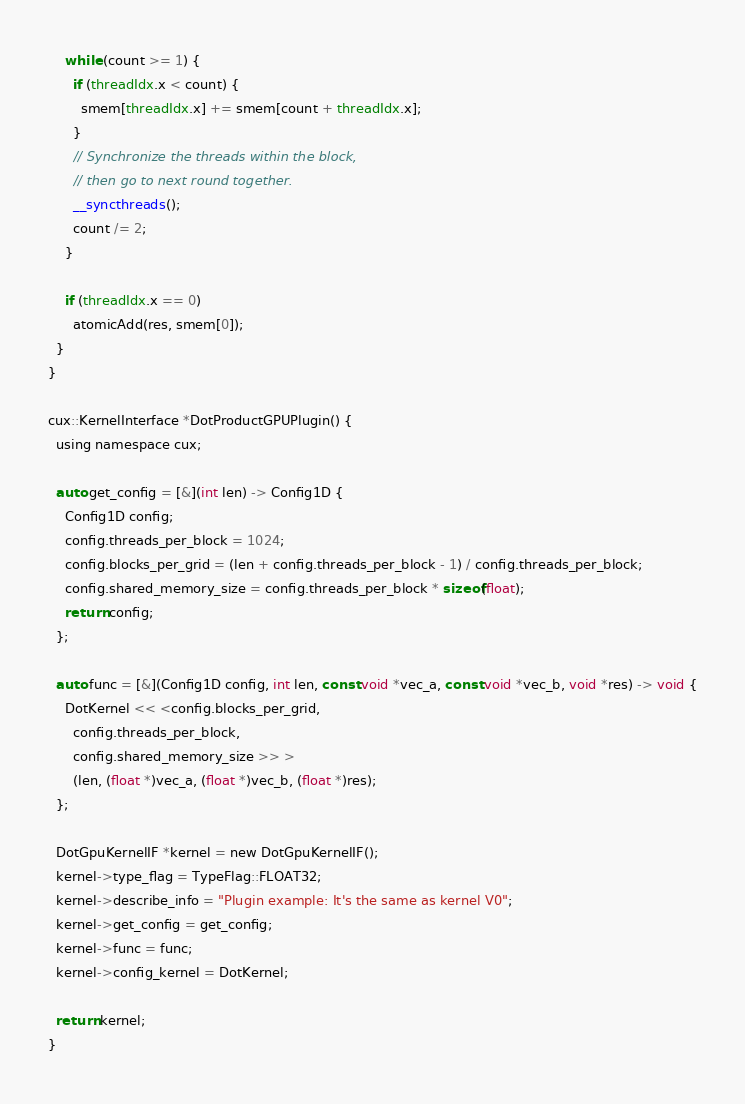<code> <loc_0><loc_0><loc_500><loc_500><_Cuda_>    while (count >= 1) {
      if (threadIdx.x < count) {
        smem[threadIdx.x] += smem[count + threadIdx.x];
      }
      // Synchronize the threads within the block,
      // then go to next round together.
      __syncthreads();
      count /= 2;
    }

    if (threadIdx.x == 0)
      atomicAdd(res, smem[0]);
  }
}

cux::KernelInterface *DotProductGPUPlugin() {
  using namespace cux;

  auto get_config = [&](int len) -> Config1D {
    Config1D config;
    config.threads_per_block = 1024;
    config.blocks_per_grid = (len + config.threads_per_block - 1) / config.threads_per_block;
    config.shared_memory_size = config.threads_per_block * sizeof(float);
    return config;
  };

  auto func = [&](Config1D config, int len, const void *vec_a, const void *vec_b, void *res) -> void {
    DotKernel << <config.blocks_per_grid,
      config.threads_per_block,
      config.shared_memory_size >> >
      (len, (float *)vec_a, (float *)vec_b, (float *)res);
  };

  DotGpuKernelIF *kernel = new DotGpuKernelIF();
  kernel->type_flag = TypeFlag::FLOAT32;
  kernel->describe_info = "Plugin example: It's the same as kernel V0";
  kernel->get_config = get_config;
  kernel->func = func;
  kernel->config_kernel = DotKernel;

  return kernel;
}</code> 